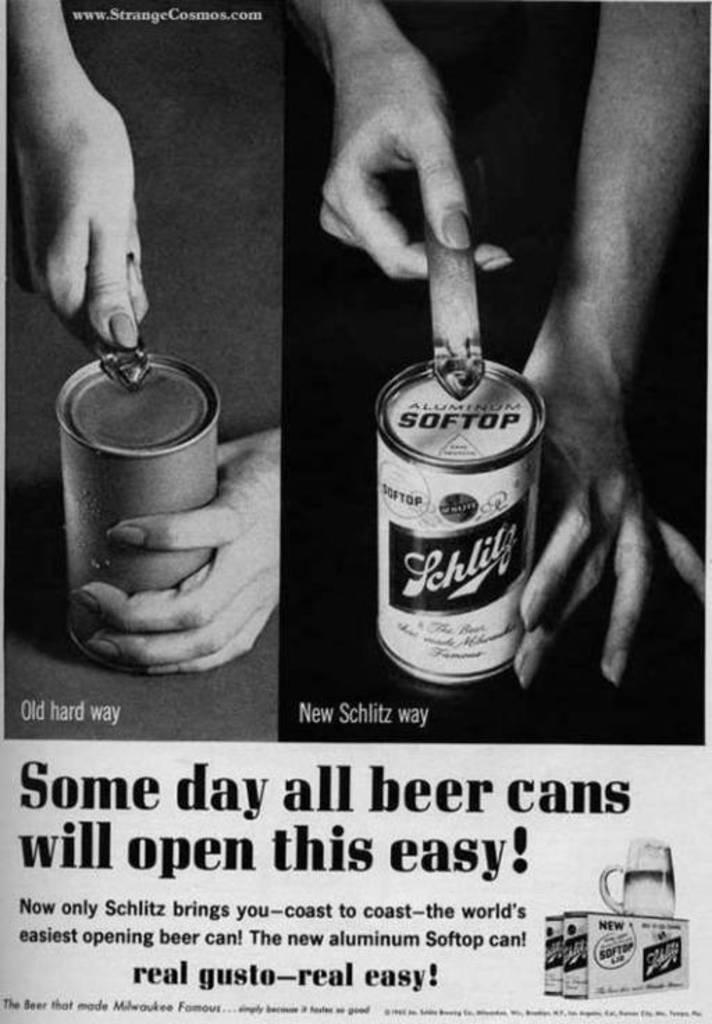What type of visual is the image? The image is a poster. What objects can be seen in the poster? There are tins, hands, and a glass in the poster. Is there any text present in the poster? Yes, there is text in the poster. How many birds are flying over the root in the poster? There are no birds or roots present in the poster; it features tins, hands, a glass, and text. 